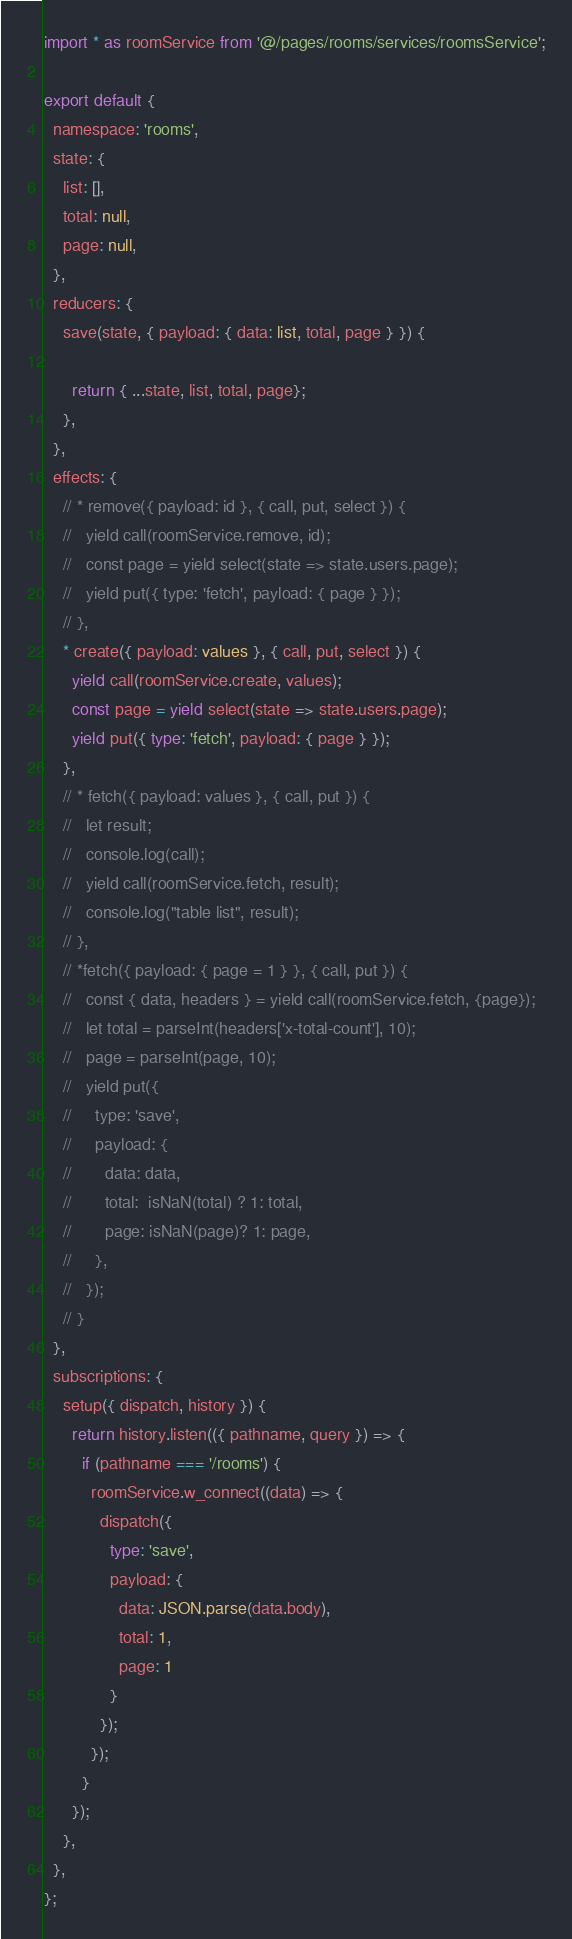Convert code to text. <code><loc_0><loc_0><loc_500><loc_500><_TypeScript_>import * as roomService from '@/pages/rooms/services/roomsService';

export default {
  namespace: 'rooms',
  state: {
    list: [],
    total: null,
    page: null,
  },
  reducers: {
    save(state, { payload: { data: list, total, page } }) {
      
      return { ...state, list, total, page};
    },
  },
  effects: {
    // * remove({ payload: id }, { call, put, select }) {
    //   yield call(roomService.remove, id);
    //   const page = yield select(state => state.users.page);
    //   yield put({ type: 'fetch', payload: { page } });
    // },
    * create({ payload: values }, { call, put, select }) {
      yield call(roomService.create, values);
      const page = yield select(state => state.users.page);
      yield put({ type: 'fetch', payload: { page } });
    },
    // * fetch({ payload: values }, { call, put }) {
    //   let result;
    //   console.log(call);
    //   yield call(roomService.fetch, result);
    //   console.log("table list", result);
    // },
    // *fetch({ payload: { page = 1 } }, { call, put }) {
    //   const { data, headers } = yield call(roomService.fetch, {page});
    //   let total = parseInt(headers['x-total-count'], 10);
    //   page = parseInt(page, 10);
    //   yield put({
    //     type: 'save',
    //     payload: {
    //       data: data,
    //       total:  isNaN(total) ? 1: total,
    //       page: isNaN(page)? 1: page,
    //     },
    //   });
    // }
  },
  subscriptions: {
    setup({ dispatch, history }) {
      return history.listen(({ pathname, query }) => {
        if (pathname === '/rooms') {
          roomService.w_connect((data) => {
            dispatch({
              type: 'save',
              payload: {	          
                data: JSON.parse(data.body),
                total: 1,	
                page: 1
              }
            });
          });
        }
      });
    },
  },
};
</code> 